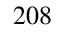Convert formula to latex. <formula><loc_0><loc_0><loc_500><loc_500>^ { 2 0 8 }</formula> 